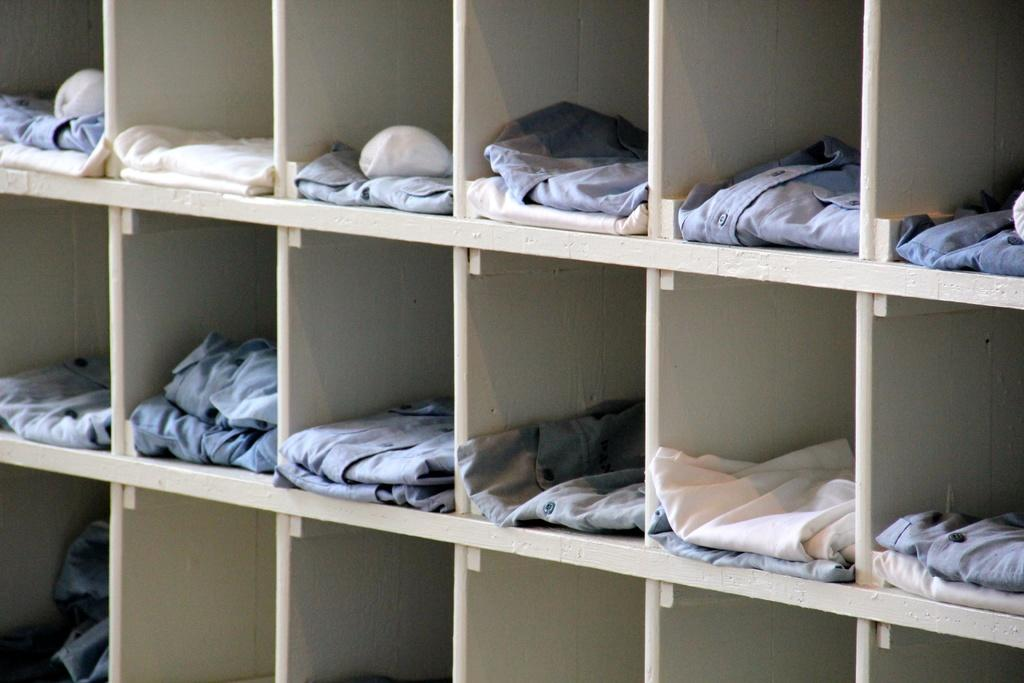Where was the image taken? The image was taken indoors. What can be seen on the shelves in the image? There are clothes on the shelves in the image. What type of apparatus can be seen on the shelves in the image? There is no apparatus present on the shelves in the image; only clothes are visible. How many brothers are visible in the image? There are no people, including brothers, present in the image. 